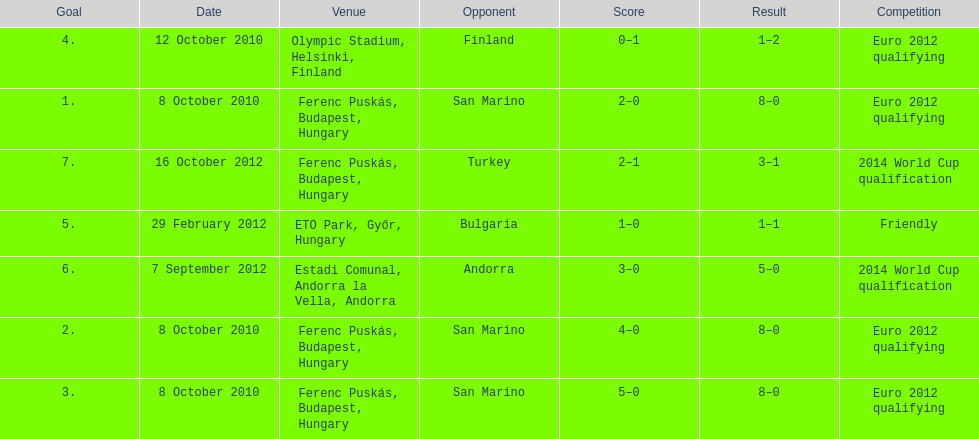In what year was szalai's first international goal? 2010. 